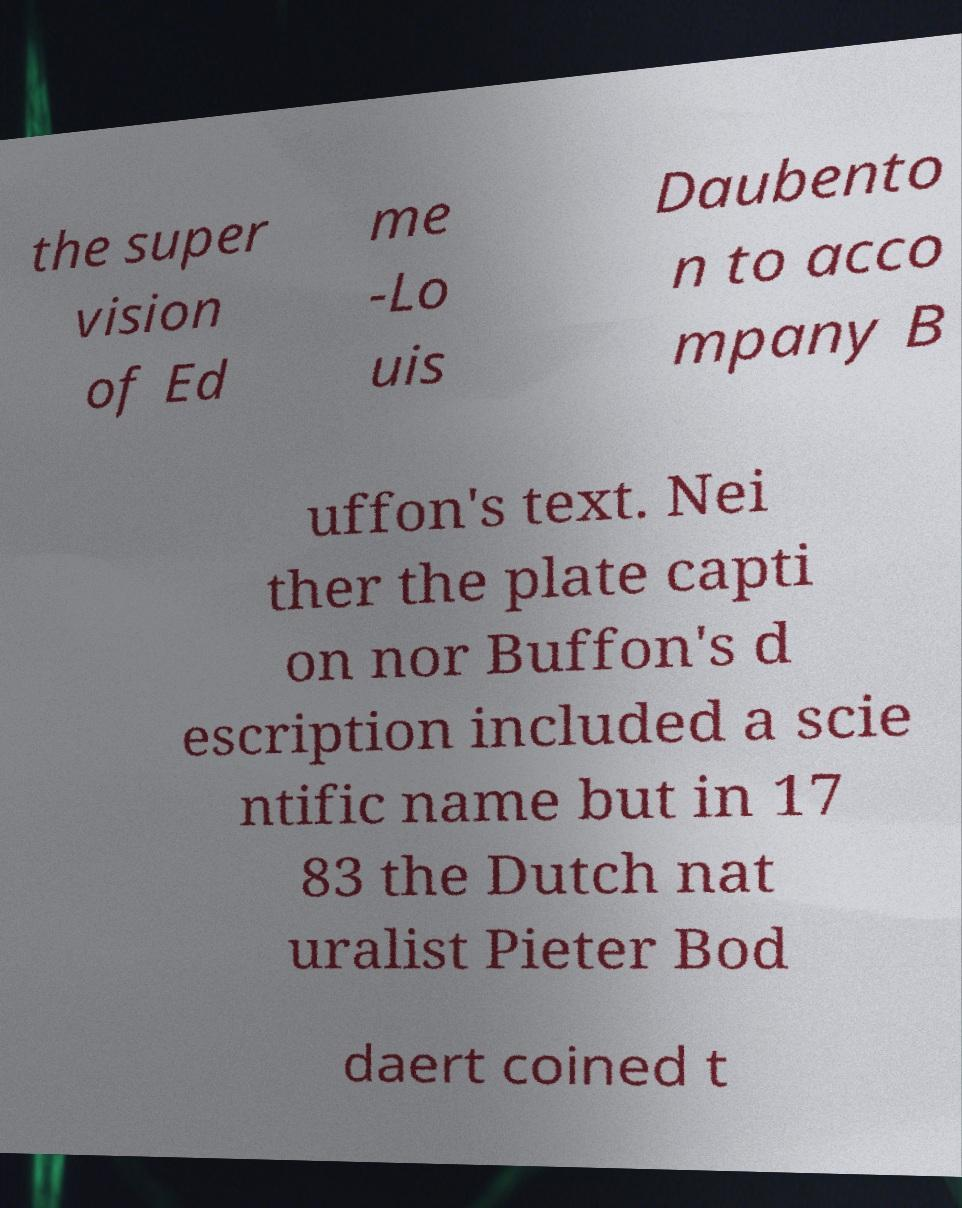There's text embedded in this image that I need extracted. Can you transcribe it verbatim? the super vision of Ed me -Lo uis Daubento n to acco mpany B uffon's text. Nei ther the plate capti on nor Buffon's d escription included a scie ntific name but in 17 83 the Dutch nat uralist Pieter Bod daert coined t 